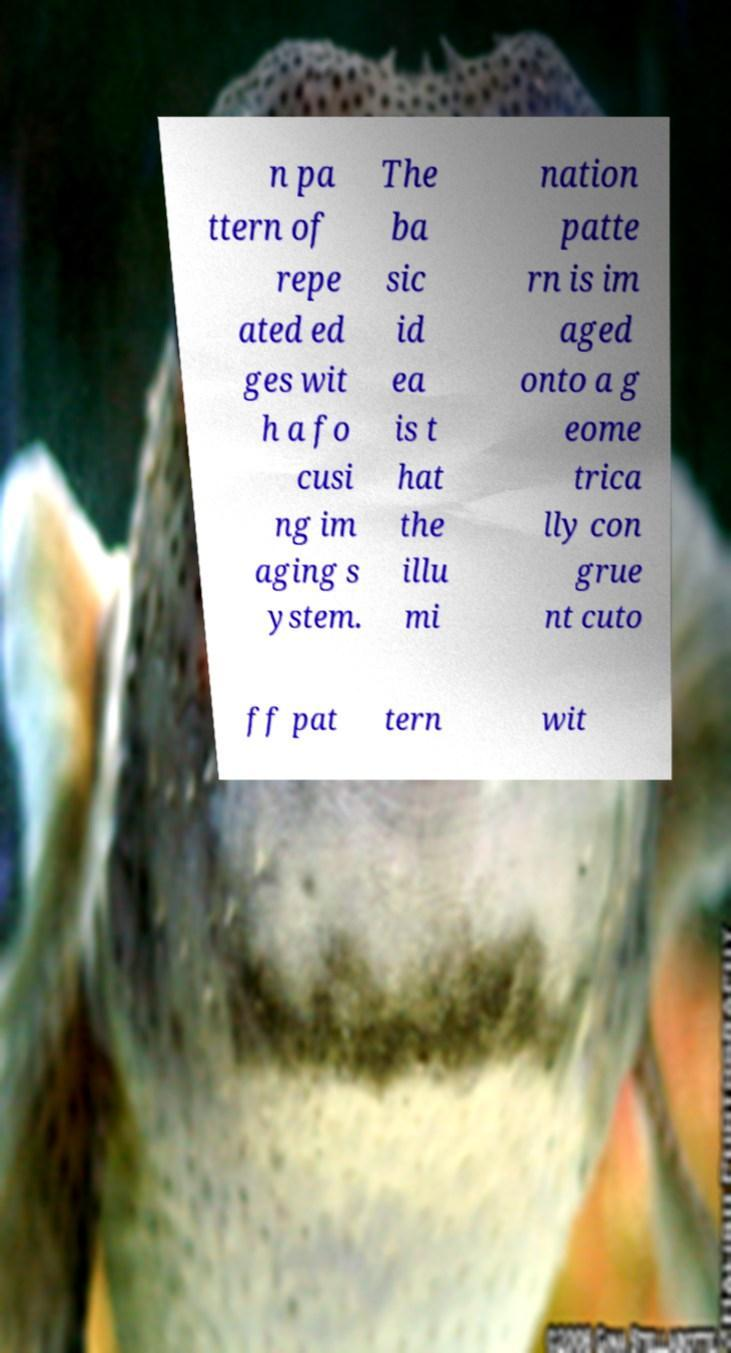I need the written content from this picture converted into text. Can you do that? n pa ttern of repe ated ed ges wit h a fo cusi ng im aging s ystem. The ba sic id ea is t hat the illu mi nation patte rn is im aged onto a g eome trica lly con grue nt cuto ff pat tern wit 